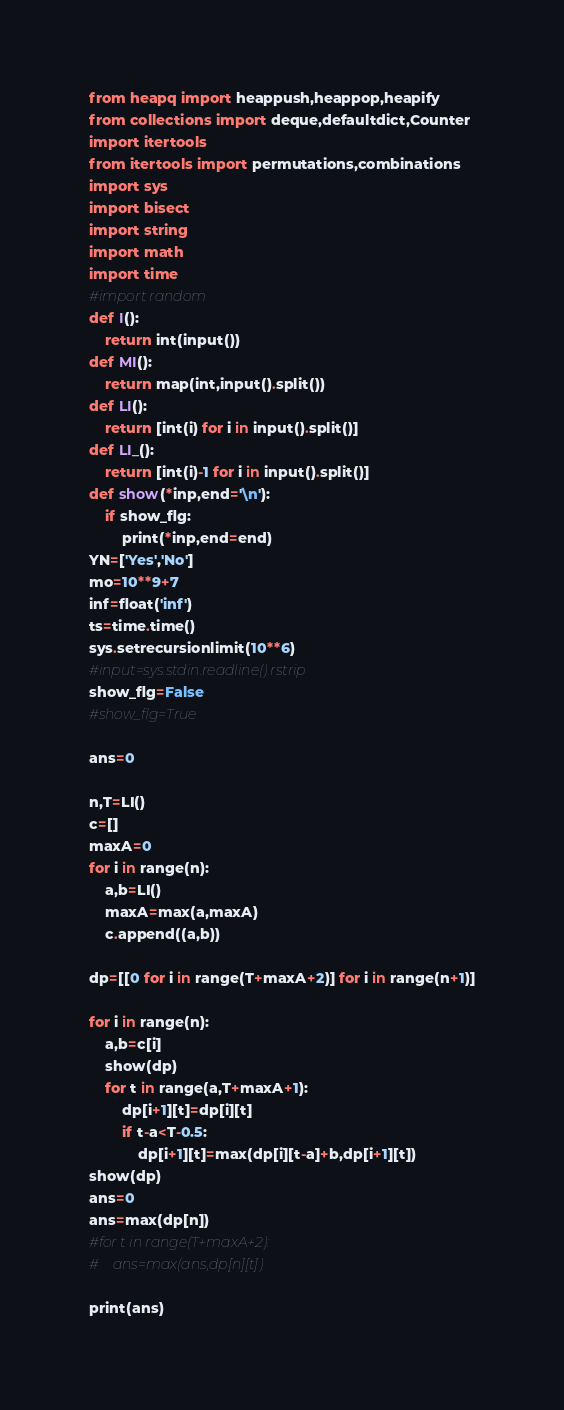Convert code to text. <code><loc_0><loc_0><loc_500><loc_500><_Python_>from heapq import heappush,heappop,heapify
from collections import deque,defaultdict,Counter
import itertools
from itertools import permutations,combinations
import sys
import bisect
import string
import math
import time
#import random
def I():
    return int(input())
def MI():
    return map(int,input().split())
def LI():
    return [int(i) for i in input().split()]
def LI_():
    return [int(i)-1 for i in input().split()]
def show(*inp,end='\n'):
    if show_flg:
        print(*inp,end=end)
YN=['Yes','No']
mo=10**9+7
inf=float('inf')
ts=time.time()
sys.setrecursionlimit(10**6)
#input=sys.stdin.readline().rstrip
show_flg=False
#show_flg=True

ans=0

n,T=LI()
c=[]
maxA=0
for i in range(n):
    a,b=LI()
    maxA=max(a,maxA)
    c.append((a,b))

dp=[[0 for i in range(T+maxA+2)] for i in range(n+1)]

for i in range(n):
    a,b=c[i]
    show(dp)
    for t in range(a,T+maxA+1):
        dp[i+1][t]=dp[i][t]
        if t-a<T-0.5:
            dp[i+1][t]=max(dp[i][t-a]+b,dp[i+1][t])
show(dp)
ans=0
ans=max(dp[n])
#for t in range(T+maxA+2):
#    ans=max(ans,dp[n][t])
        
print(ans)</code> 